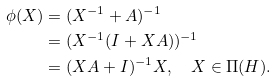Convert formula to latex. <formula><loc_0><loc_0><loc_500><loc_500>\phi ( X ) & = ( X ^ { - 1 } + A ) ^ { - 1 } \\ & = ( X ^ { - 1 } ( I + X A ) ) ^ { - 1 } \\ & = ( X A + I ) ^ { - 1 } X , \quad X \in { \Pi } ( H ) .</formula> 